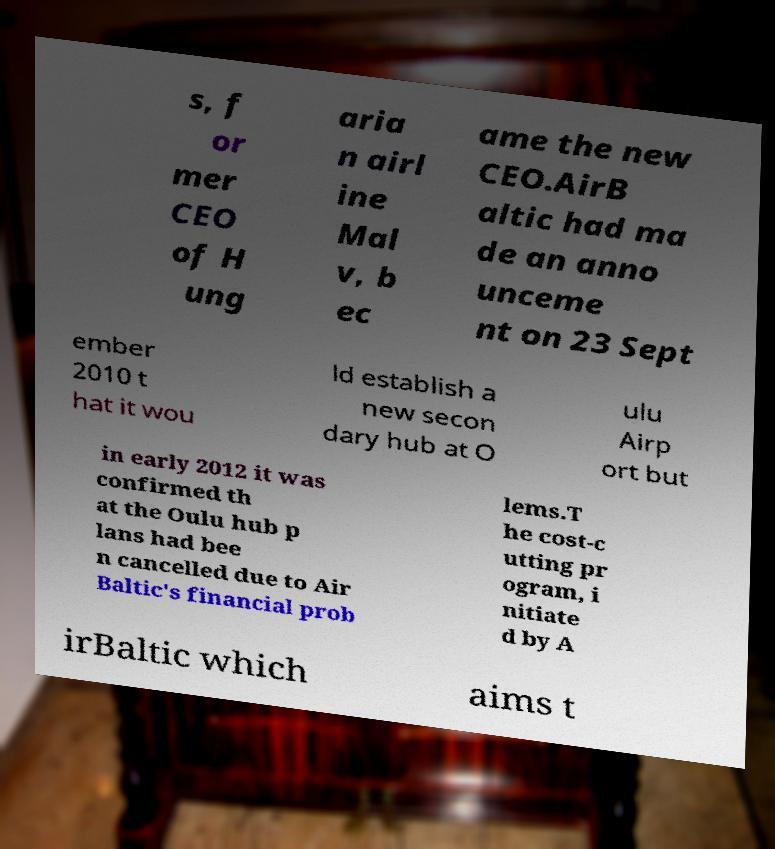I need the written content from this picture converted into text. Can you do that? s, f or mer CEO of H ung aria n airl ine Mal v, b ec ame the new CEO.AirB altic had ma de an anno unceme nt on 23 Sept ember 2010 t hat it wou ld establish a new secon dary hub at O ulu Airp ort but in early 2012 it was confirmed th at the Oulu hub p lans had bee n cancelled due to Air Baltic's financial prob lems.T he cost-c utting pr ogram, i nitiate d by A irBaltic which aims t 